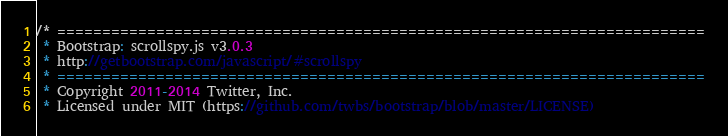<code> <loc_0><loc_0><loc_500><loc_500><_JavaScript_>/* ========================================================================
 * Bootstrap: scrollspy.js v3.0.3
 * http://getbootstrap.com/javascript/#scrollspy
 * ========================================================================
 * Copyright 2011-2014 Twitter, Inc.
 * Licensed under MIT (https://github.com/twbs/bootstrap/blob/master/LICENSE)</code> 